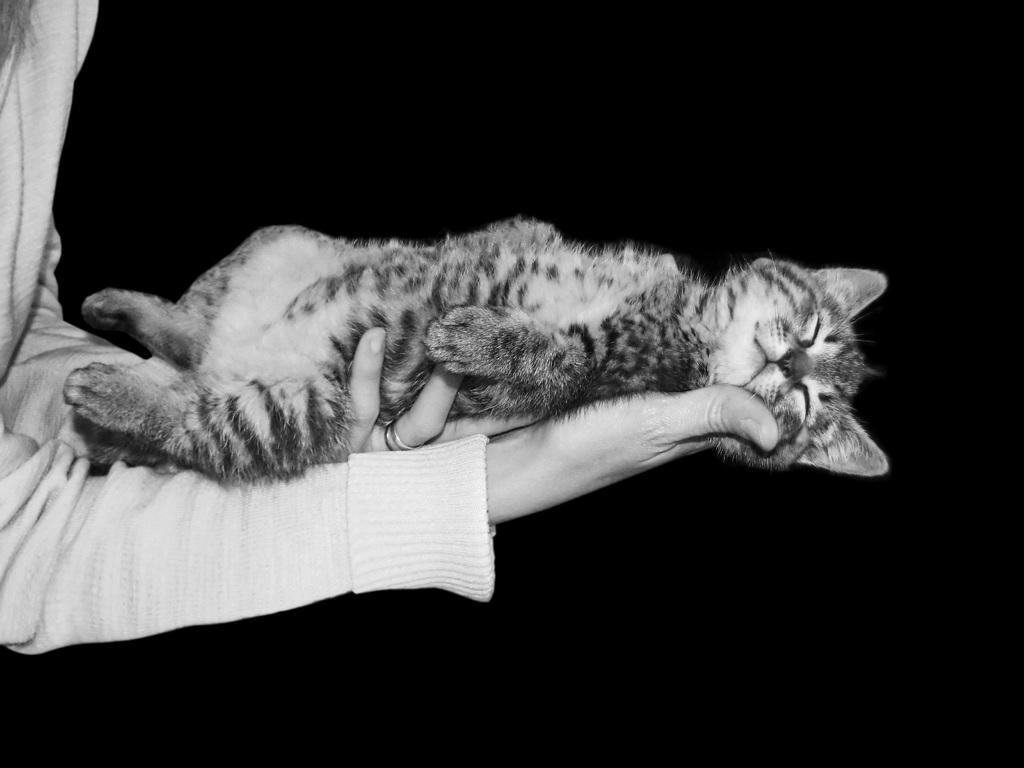What is the main subject of the image? There is a person in the image. What is the person holding in the image? The person is holding a cat. What color is the background of the image? The background of the image is black. What type of zephyr can be seen in the image? There is no zephyr present in the image. What educational institution is visible in the image? There is no educational institution present in the image. 